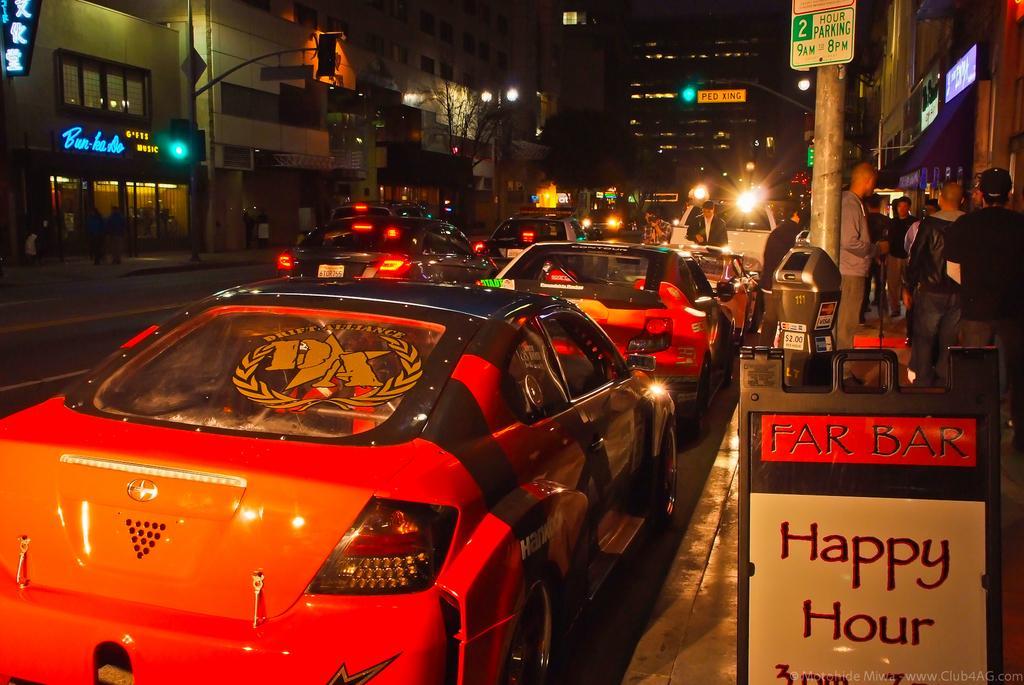Describe this image in one or two sentences. In this image there are so many cars on the road, beside them there are so many buildings and also there are some electrical poles in front of them. 